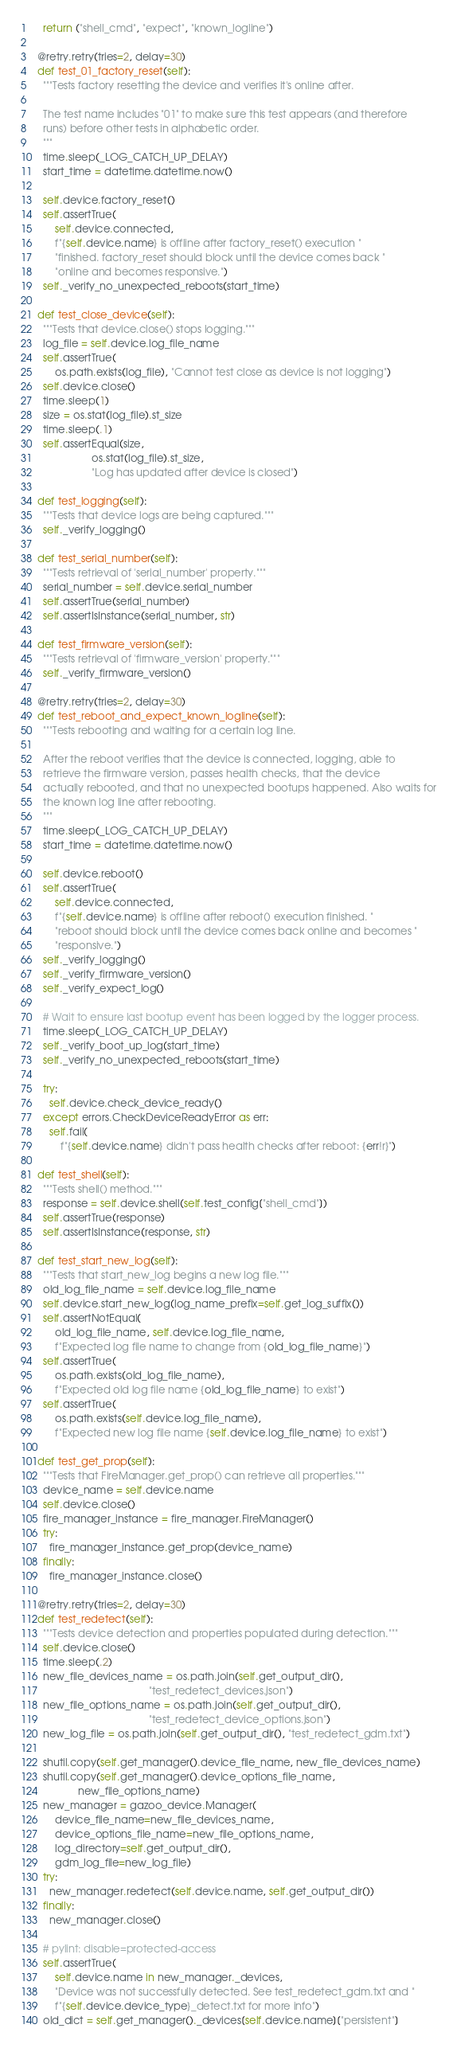Convert code to text. <code><loc_0><loc_0><loc_500><loc_500><_Python_>    return ("shell_cmd", "expect", "known_logline")

  @retry.retry(tries=2, delay=30)
  def test_01_factory_reset(self):
    """Tests factory resetting the device and verifies it's online after.

    The test name includes "01" to make sure this test appears (and therefore
    runs) before other tests in alphabetic order.
    """
    time.sleep(_LOG_CATCH_UP_DELAY)
    start_time = datetime.datetime.now()

    self.device.factory_reset()
    self.assertTrue(
        self.device.connected,
        f"{self.device.name} is offline after factory_reset() execution "
        "finished. factory_reset should block until the device comes back "
        "online and becomes responsive.")
    self._verify_no_unexpected_reboots(start_time)

  def test_close_device(self):
    """Tests that device.close() stops logging."""
    log_file = self.device.log_file_name
    self.assertTrue(
        os.path.exists(log_file), "Cannot test close as device is not logging")
    self.device.close()
    time.sleep(1)
    size = os.stat(log_file).st_size
    time.sleep(.1)
    self.assertEqual(size,
                     os.stat(log_file).st_size,
                     "Log has updated after device is closed")

  def test_logging(self):
    """Tests that device logs are being captured."""
    self._verify_logging()

  def test_serial_number(self):
    """Tests retrieval of 'serial_number' property."""
    serial_number = self.device.serial_number
    self.assertTrue(serial_number)
    self.assertIsInstance(serial_number, str)

  def test_firmware_version(self):
    """Tests retrieval of 'firmware_version' property."""
    self._verify_firmware_version()

  @retry.retry(tries=2, delay=30)
  def test_reboot_and_expect_known_logline(self):
    """Tests rebooting and waiting for a certain log line.

    After the reboot verifies that the device is connected, logging, able to
    retrieve the firmware version, passes health checks, that the device
    actually rebooted, and that no unexpected bootups happened. Also waits for
    the known log line after rebooting.
    """
    time.sleep(_LOG_CATCH_UP_DELAY)
    start_time = datetime.datetime.now()

    self.device.reboot()
    self.assertTrue(
        self.device.connected,
        f"{self.device.name} is offline after reboot() execution finished. "
        "reboot should block until the device comes back online and becomes "
        "responsive.")
    self._verify_logging()
    self._verify_firmware_version()
    self._verify_expect_log()

    # Wait to ensure last bootup event has been logged by the logger process.
    time.sleep(_LOG_CATCH_UP_DELAY)
    self._verify_boot_up_log(start_time)
    self._verify_no_unexpected_reboots(start_time)

    try:
      self.device.check_device_ready()
    except errors.CheckDeviceReadyError as err:
      self.fail(
          f"{self.device.name} didn't pass health checks after reboot: {err!r}")

  def test_shell(self):
    """Tests shell() method."""
    response = self.device.shell(self.test_config["shell_cmd"])
    self.assertTrue(response)
    self.assertIsInstance(response, str)

  def test_start_new_log(self):
    """Tests that start_new_log begins a new log file."""
    old_log_file_name = self.device.log_file_name
    self.device.start_new_log(log_name_prefix=self.get_log_suffix())
    self.assertNotEqual(
        old_log_file_name, self.device.log_file_name,
        f"Expected log file name to change from {old_log_file_name}")
    self.assertTrue(
        os.path.exists(old_log_file_name),
        f"Expected old log file name {old_log_file_name} to exist")
    self.assertTrue(
        os.path.exists(self.device.log_file_name),
        f"Expected new log file name {self.device.log_file_name} to exist")

  def test_get_prop(self):
    """Tests that FireManager.get_prop() can retrieve all properties."""
    device_name = self.device.name
    self.device.close()
    fire_manager_instance = fire_manager.FireManager()
    try:
      fire_manager_instance.get_prop(device_name)
    finally:
      fire_manager_instance.close()

  @retry.retry(tries=2, delay=30)
  def test_redetect(self):
    """Tests device detection and properties populated during detection."""
    self.device.close()
    time.sleep(.2)
    new_file_devices_name = os.path.join(self.get_output_dir(),
                                         "test_redetect_devices.json")
    new_file_options_name = os.path.join(self.get_output_dir(),
                                         "test_redetect_device_options.json")
    new_log_file = os.path.join(self.get_output_dir(), "test_redetect_gdm.txt")

    shutil.copy(self.get_manager().device_file_name, new_file_devices_name)
    shutil.copy(self.get_manager().device_options_file_name,
                new_file_options_name)
    new_manager = gazoo_device.Manager(
        device_file_name=new_file_devices_name,
        device_options_file_name=new_file_options_name,
        log_directory=self.get_output_dir(),
        gdm_log_file=new_log_file)
    try:
      new_manager.redetect(self.device.name, self.get_output_dir())
    finally:
      new_manager.close()

    # pylint: disable=protected-access
    self.assertTrue(
        self.device.name in new_manager._devices,
        "Device was not successfully detected. See test_redetect_gdm.txt and "
        f"{self.device.device_type}_detect.txt for more info")
    old_dict = self.get_manager()._devices[self.device.name]["persistent"]</code> 